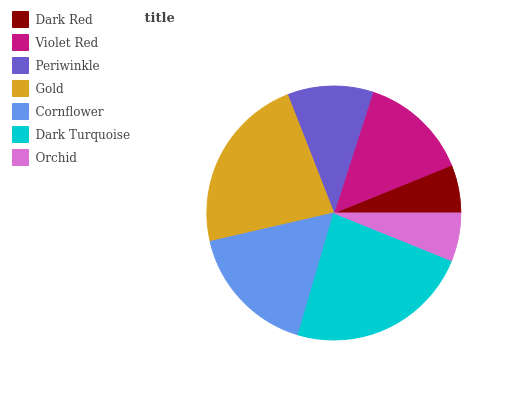Is Orchid the minimum?
Answer yes or no. Yes. Is Dark Turquoise the maximum?
Answer yes or no. Yes. Is Violet Red the minimum?
Answer yes or no. No. Is Violet Red the maximum?
Answer yes or no. No. Is Violet Red greater than Dark Red?
Answer yes or no. Yes. Is Dark Red less than Violet Red?
Answer yes or no. Yes. Is Dark Red greater than Violet Red?
Answer yes or no. No. Is Violet Red less than Dark Red?
Answer yes or no. No. Is Violet Red the high median?
Answer yes or no. Yes. Is Violet Red the low median?
Answer yes or no. Yes. Is Orchid the high median?
Answer yes or no. No. Is Gold the low median?
Answer yes or no. No. 